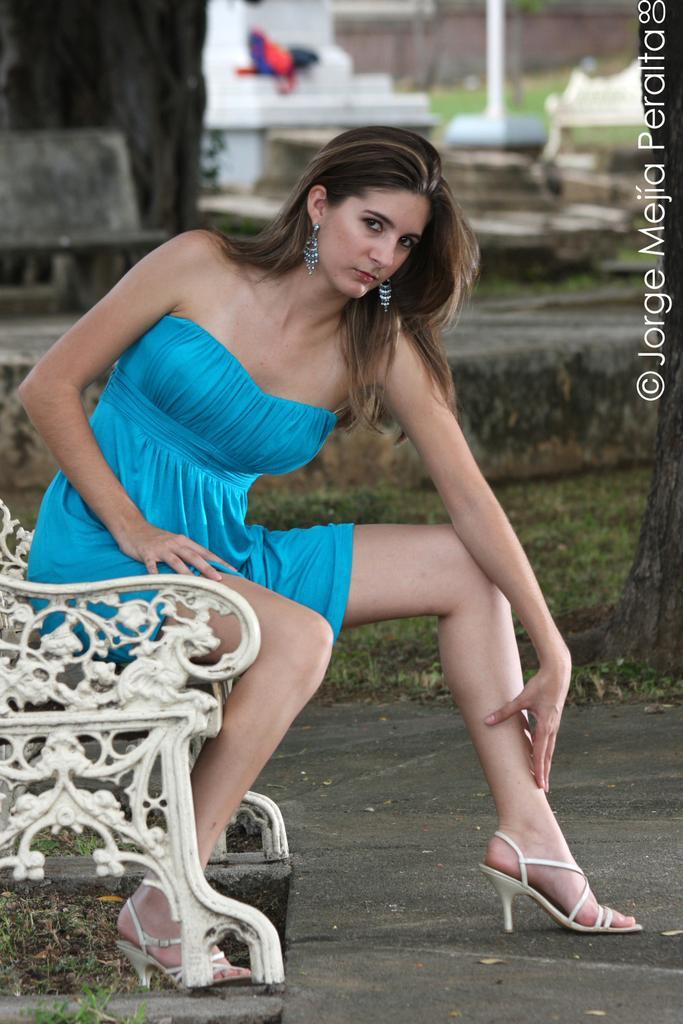In one or two sentences, can you explain what this image depicts? As we can see in the image in the front there is a woman wearing sky blue color dress and sitting on bench. In the background there are houses and grass. 